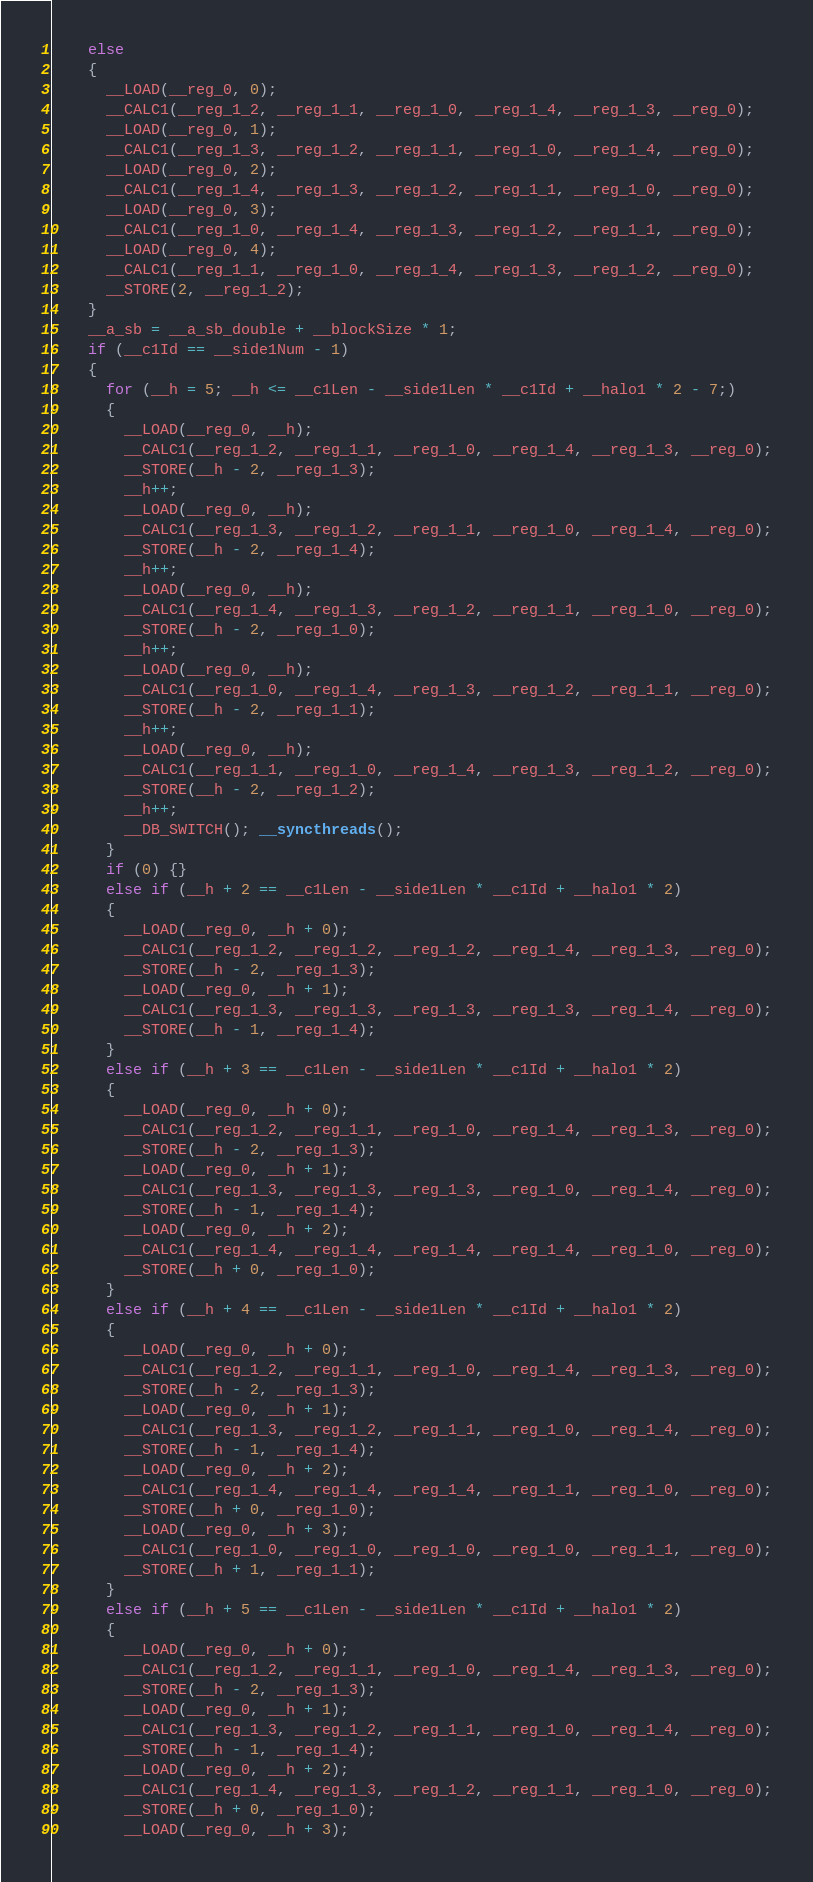<code> <loc_0><loc_0><loc_500><loc_500><_Cuda_>    else
    {
      __LOAD(__reg_0, 0);
      __CALC1(__reg_1_2, __reg_1_1, __reg_1_0, __reg_1_4, __reg_1_3, __reg_0);
      __LOAD(__reg_0, 1);
      __CALC1(__reg_1_3, __reg_1_2, __reg_1_1, __reg_1_0, __reg_1_4, __reg_0);
      __LOAD(__reg_0, 2);
      __CALC1(__reg_1_4, __reg_1_3, __reg_1_2, __reg_1_1, __reg_1_0, __reg_0);
      __LOAD(__reg_0, 3);
      __CALC1(__reg_1_0, __reg_1_4, __reg_1_3, __reg_1_2, __reg_1_1, __reg_0);
      __LOAD(__reg_0, 4);
      __CALC1(__reg_1_1, __reg_1_0, __reg_1_4, __reg_1_3, __reg_1_2, __reg_0);
      __STORE(2, __reg_1_2);
    }
    __a_sb = __a_sb_double + __blockSize * 1;
    if (__c1Id == __side1Num - 1)
    {
      for (__h = 5; __h <= __c1Len - __side1Len * __c1Id + __halo1 * 2 - 7;)
      {
        __LOAD(__reg_0, __h);
        __CALC1(__reg_1_2, __reg_1_1, __reg_1_0, __reg_1_4, __reg_1_3, __reg_0);
        __STORE(__h - 2, __reg_1_3);
        __h++;
        __LOAD(__reg_0, __h);
        __CALC1(__reg_1_3, __reg_1_2, __reg_1_1, __reg_1_0, __reg_1_4, __reg_0);
        __STORE(__h - 2, __reg_1_4);
        __h++;
        __LOAD(__reg_0, __h);
        __CALC1(__reg_1_4, __reg_1_3, __reg_1_2, __reg_1_1, __reg_1_0, __reg_0);
        __STORE(__h - 2, __reg_1_0);
        __h++;
        __LOAD(__reg_0, __h);
        __CALC1(__reg_1_0, __reg_1_4, __reg_1_3, __reg_1_2, __reg_1_1, __reg_0);
        __STORE(__h - 2, __reg_1_1);
        __h++;
        __LOAD(__reg_0, __h);
        __CALC1(__reg_1_1, __reg_1_0, __reg_1_4, __reg_1_3, __reg_1_2, __reg_0);
        __STORE(__h - 2, __reg_1_2);
        __h++;
        __DB_SWITCH(); __syncthreads();
      }
      if (0) {}
      else if (__h + 2 == __c1Len - __side1Len * __c1Id + __halo1 * 2)
      {
        __LOAD(__reg_0, __h + 0);
        __CALC1(__reg_1_2, __reg_1_2, __reg_1_2, __reg_1_4, __reg_1_3, __reg_0);
        __STORE(__h - 2, __reg_1_3);
        __LOAD(__reg_0, __h + 1);
        __CALC1(__reg_1_3, __reg_1_3, __reg_1_3, __reg_1_3, __reg_1_4, __reg_0);
        __STORE(__h - 1, __reg_1_4);
      }
      else if (__h + 3 == __c1Len - __side1Len * __c1Id + __halo1 * 2)
      {
        __LOAD(__reg_0, __h + 0);
        __CALC1(__reg_1_2, __reg_1_1, __reg_1_0, __reg_1_4, __reg_1_3, __reg_0);
        __STORE(__h - 2, __reg_1_3);
        __LOAD(__reg_0, __h + 1);
        __CALC1(__reg_1_3, __reg_1_3, __reg_1_3, __reg_1_0, __reg_1_4, __reg_0);
        __STORE(__h - 1, __reg_1_4);
        __LOAD(__reg_0, __h + 2);
        __CALC1(__reg_1_4, __reg_1_4, __reg_1_4, __reg_1_4, __reg_1_0, __reg_0);
        __STORE(__h + 0, __reg_1_0);
      }
      else if (__h + 4 == __c1Len - __side1Len * __c1Id + __halo1 * 2)
      {
        __LOAD(__reg_0, __h + 0);
        __CALC1(__reg_1_2, __reg_1_1, __reg_1_0, __reg_1_4, __reg_1_3, __reg_0);
        __STORE(__h - 2, __reg_1_3);
        __LOAD(__reg_0, __h + 1);
        __CALC1(__reg_1_3, __reg_1_2, __reg_1_1, __reg_1_0, __reg_1_4, __reg_0);
        __STORE(__h - 1, __reg_1_4);
        __LOAD(__reg_0, __h + 2);
        __CALC1(__reg_1_4, __reg_1_4, __reg_1_4, __reg_1_1, __reg_1_0, __reg_0);
        __STORE(__h + 0, __reg_1_0);
        __LOAD(__reg_0, __h + 3);
        __CALC1(__reg_1_0, __reg_1_0, __reg_1_0, __reg_1_0, __reg_1_1, __reg_0);
        __STORE(__h + 1, __reg_1_1);
      }
      else if (__h + 5 == __c1Len - __side1Len * __c1Id + __halo1 * 2)
      {
        __LOAD(__reg_0, __h + 0);
        __CALC1(__reg_1_2, __reg_1_1, __reg_1_0, __reg_1_4, __reg_1_3, __reg_0);
        __STORE(__h - 2, __reg_1_3);
        __LOAD(__reg_0, __h + 1);
        __CALC1(__reg_1_3, __reg_1_2, __reg_1_1, __reg_1_0, __reg_1_4, __reg_0);
        __STORE(__h - 1, __reg_1_4);
        __LOAD(__reg_0, __h + 2);
        __CALC1(__reg_1_4, __reg_1_3, __reg_1_2, __reg_1_1, __reg_1_0, __reg_0);
        __STORE(__h + 0, __reg_1_0);
        __LOAD(__reg_0, __h + 3);</code> 